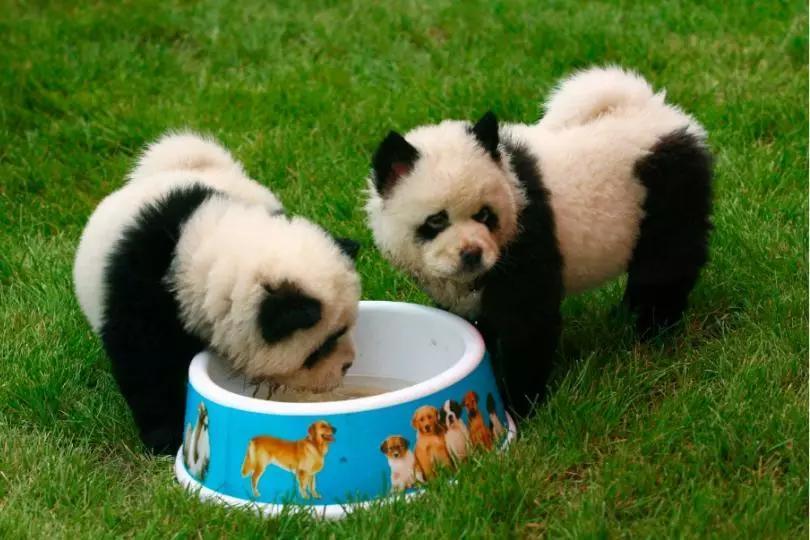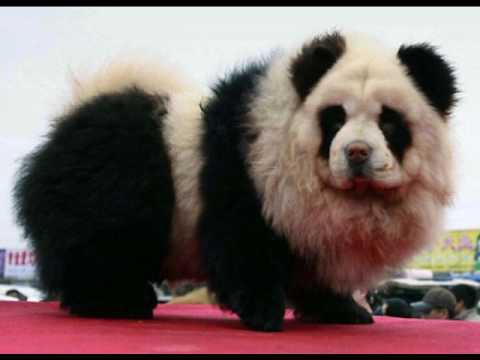The first image is the image on the left, the second image is the image on the right. Given the left and right images, does the statement "There's at least three dogs in the right image." hold true? Answer yes or no. No. The first image is the image on the left, the second image is the image on the right. Considering the images on both sides, is "An image shows three panda-look chows, with one reclining and two sitting up." valid? Answer yes or no. No. 